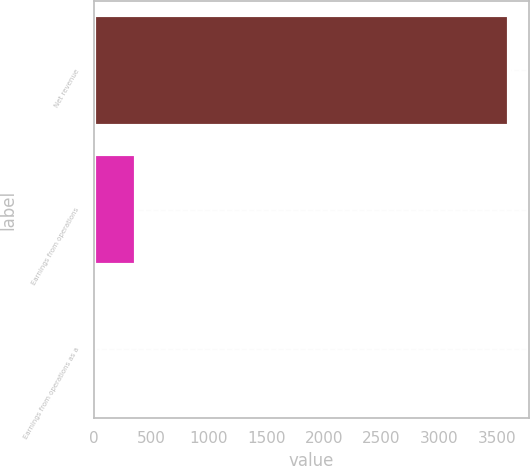Convert chart to OTSL. <chart><loc_0><loc_0><loc_500><loc_500><bar_chart><fcel>Net revenue<fcel>Earnings from operations<fcel>Earnings from operations as a<nl><fcel>3602<fcel>367.76<fcel>8.4<nl></chart> 